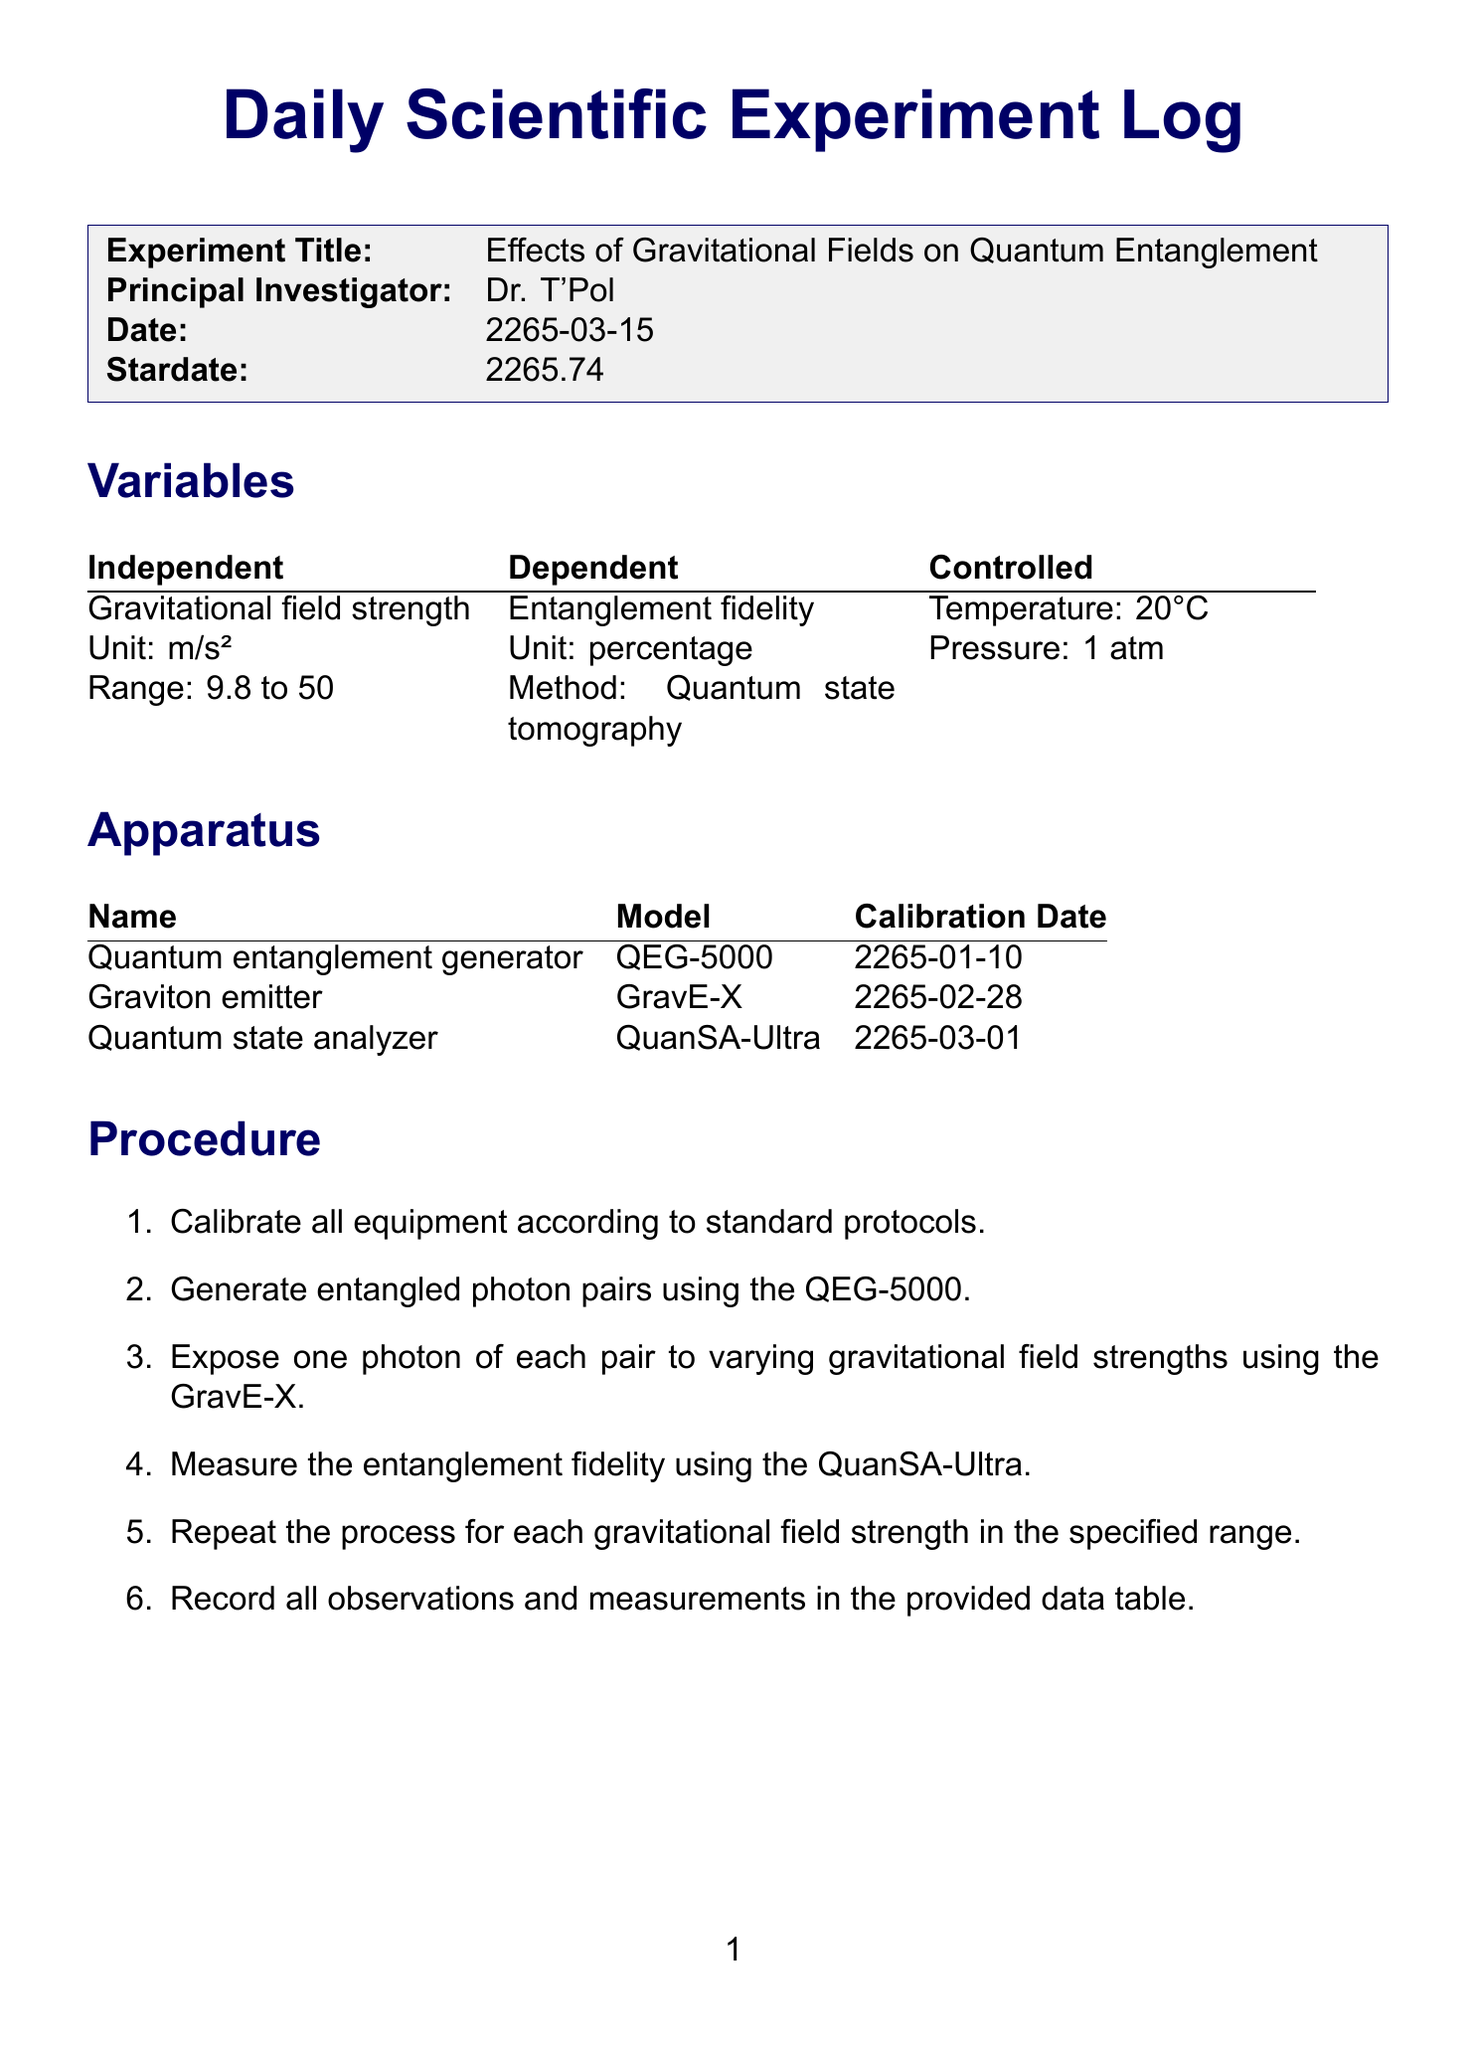what is the experiment title? The experiment title is clearly stated in the header section of the document.
Answer: Effects of Gravitational Fields on Quantum Entanglement who is the principal investigator? The principal investigator's name is listed right under the experiment title in the header.
Answer: Dr. T'Pol what is the date of the experiment? The date is mentioned in the document header, indicating when the experiment took place.
Answer: 2265-03-15 what is the range of gravitational field strength? The range of the independent variable is described in the variables section of the document.
Answer: 9.8 to 50 what is the mean entanglement fidelity? The mean value is provided in the results section under statistical analysis.
Answer: 96.15 what is the dependent variable? The dependent variable is detailed in the variables section of the document.
Answer: Entanglement fidelity how many trials were conducted? The number of trials can be inferred from the results table in the document.
Answer: 4 what significant trend was observed in the conclusions? The conclusions discuss the relationship between two variables analyzed during the experiment.
Answer: Inverse relationship what recommendations are made for future experiments? Future recommendations are found in the final section of the document, outlining proposed further research.
Answer: Investigate the precise mechanism by which gravity affects quantum entanglement 